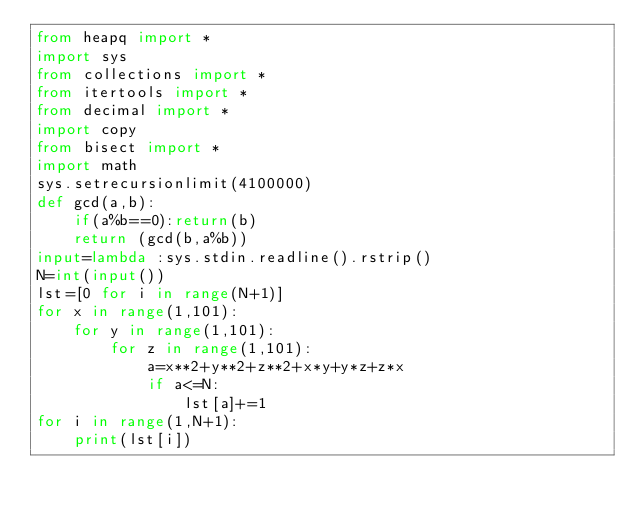Convert code to text. <code><loc_0><loc_0><loc_500><loc_500><_Python_>from heapq import *
import sys
from collections import *
from itertools import *
from decimal import *
import copy
from bisect import *
import math
sys.setrecursionlimit(4100000)
def gcd(a,b):
    if(a%b==0):return(b)
    return (gcd(b,a%b))
input=lambda :sys.stdin.readline().rstrip()
N=int(input())
lst=[0 for i in range(N+1)]
for x in range(1,101):
    for y in range(1,101):
        for z in range(1,101):
            a=x**2+y**2+z**2+x*y+y*z+z*x
            if a<=N:
                lst[a]+=1
for i in range(1,N+1):
    print(lst[i])
</code> 